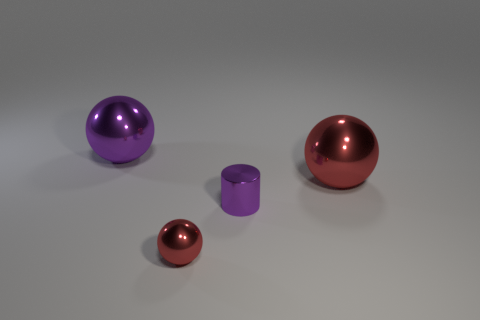Are all objects in the image solid, or are some of them possibly hollow? Without additional information it's not possible to determine the solidity of the objects from the image alone, but typically in such renderings, objects tend to be depicted as solid. 